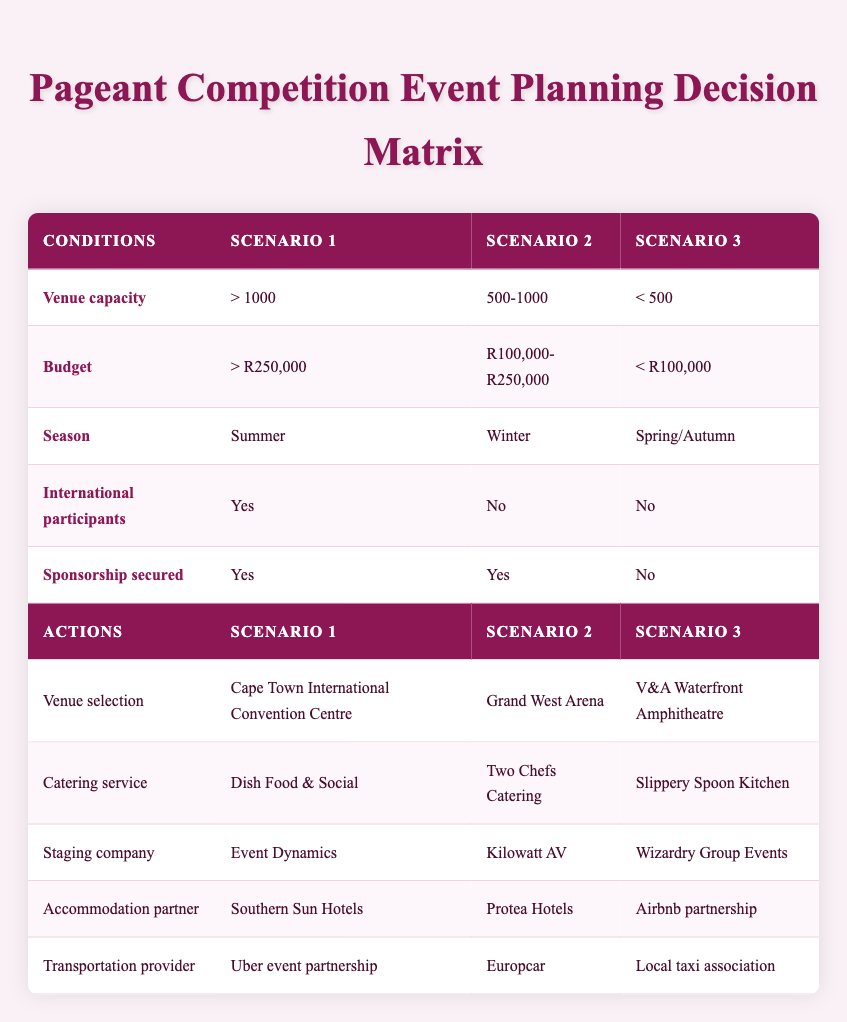What venue is selected when the budget is greater than R250,000? According to the table, for a budget condition of greater than R250,000, the selected venue is the Cape Town International Convention Centre in Scenario 1.
Answer: Cape Town International Convention Centre Are there any scenarios where international participants are not included? In the table, Scenario 2 and Scenario 3 both indicate 'No' for the international participants condition. Therefore, there are two scenarios without international participants.
Answer: Yes Which catering service is chosen for an event during Winter? Reviewing the table, Scenario 2 indicates that during the Winter season, the catering service selected is Two Chefs Catering.
Answer: Two Chefs Catering What is the transportation provider for events with a venue capacity of less than 500? According to the table, Scenario 3 shows that for a venue capacity of less than 500, the transportation provider is the Local taxi association.
Answer: Local taxi association Which staging company is selected if sponsorship is secured and the budget is between R100,000 and R250,000? The table specifies that for Scenario 2, where sponsorship is secured and the budget falls between R100,000 and R250,000, the staging company selected is Kilowatt AV.
Answer: Kilowatt AV If the venue capacity is greater than 1000 and the season is Summer, what is the accommodation partner? Looking at Scenario 1 in the table, with a venue capacity greater than 1000 and during the Summer season, the accommodation partner selected is Southern Sun Hotels.
Answer: Southern Sun Hotels How many scenarios have the same catering service of Slippery Spoon Kitchen? Upon examining the table, it is evident that only Scenario 3 has Slippery Spoon Kitchen as its catering service. Therefore, there is one scenario with this catering service.
Answer: 1 What is the relationship between sponsorship secured and catering service for events in Spring/Autumn? According to Scenario 3, if sponsorship is not secured (No), the catering service is Slippery Spoon Kitchen. There is a direct relationship showing that the service chosen here is contingent on the sponsorship status.
Answer: Slippery Spoon Kitchen Which venue is chosen in a scenario where there are no international participants and the budget is less than R100,000? Checking Scenario 3, it states that when there are no international participants and the budget condition is less than R100,000, the chosen venue is the V&A Waterfront Amphitheatre.
Answer: V&A Waterfront Amphitheatre 